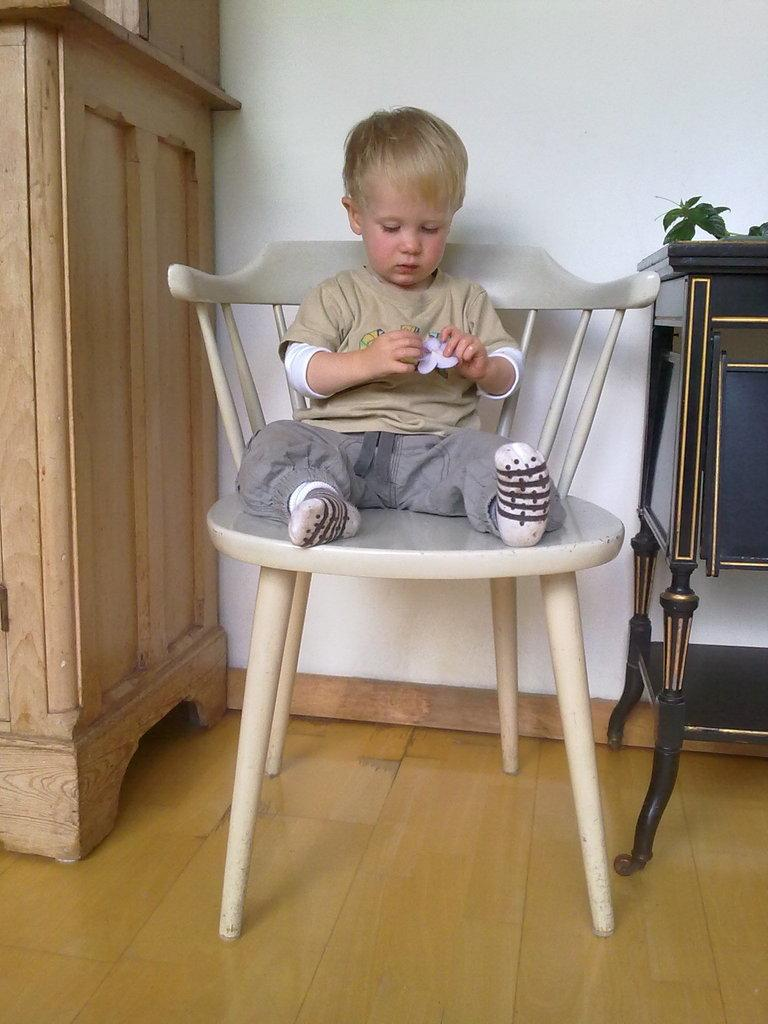Who is the main subject in the image? There is a boy in the image. What is the boy doing in the image? The boy is sitting on a chair. What object is located next to the boy? There is a stand next to the boy. What can be seen in the background of the image? There is a wall in the background of the image. What type of rice is being cooked by the boy in the image? There is no rice present in the image, and the boy is not cooking anything. 